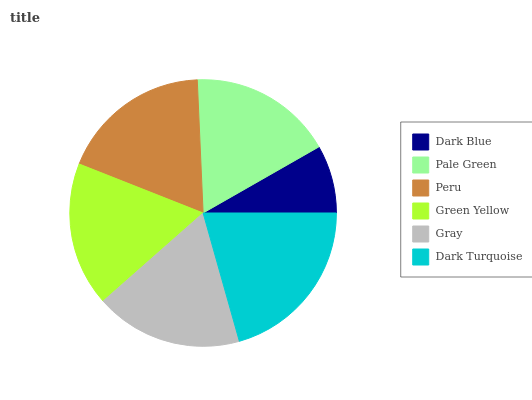Is Dark Blue the minimum?
Answer yes or no. Yes. Is Dark Turquoise the maximum?
Answer yes or no. Yes. Is Pale Green the minimum?
Answer yes or no. No. Is Pale Green the maximum?
Answer yes or no. No. Is Pale Green greater than Dark Blue?
Answer yes or no. Yes. Is Dark Blue less than Pale Green?
Answer yes or no. Yes. Is Dark Blue greater than Pale Green?
Answer yes or no. No. Is Pale Green less than Dark Blue?
Answer yes or no. No. Is Gray the high median?
Answer yes or no. Yes. Is Green Yellow the low median?
Answer yes or no. Yes. Is Green Yellow the high median?
Answer yes or no. No. Is Gray the low median?
Answer yes or no. No. 